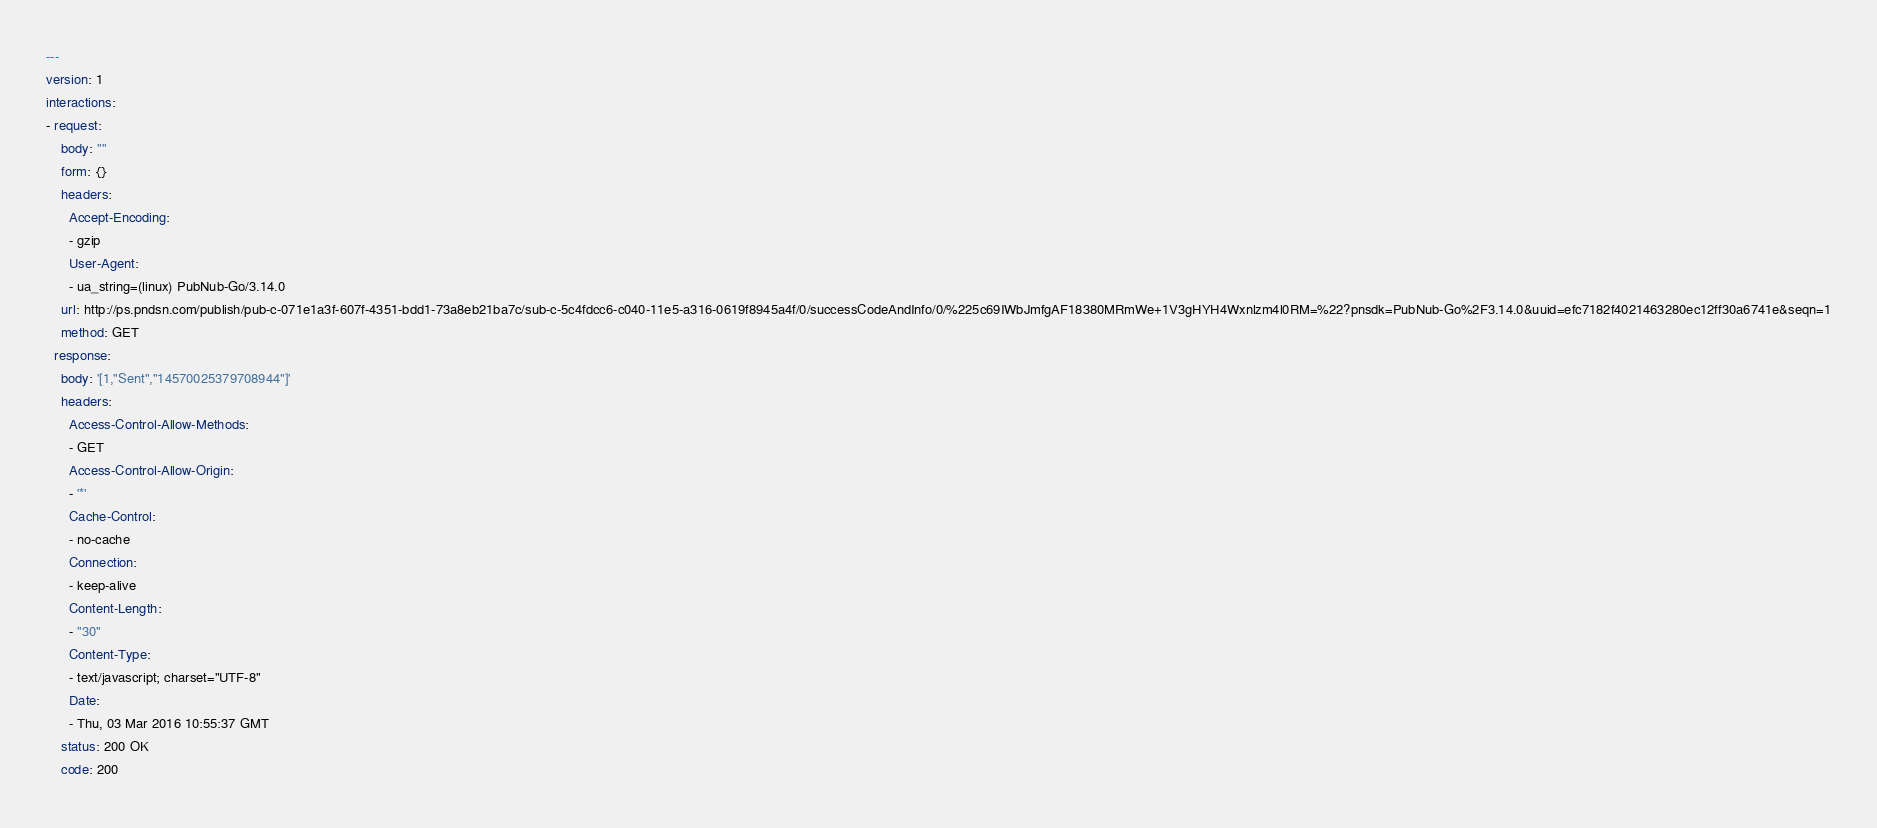<code> <loc_0><loc_0><loc_500><loc_500><_YAML_>---
version: 1
interactions:
- request:
    body: ""
    form: {}
    headers:
      Accept-Encoding:
      - gzip
      User-Agent:
      - ua_string=(linux) PubNub-Go/3.14.0
    url: http://ps.pndsn.com/publish/pub-c-071e1a3f-607f-4351-bdd1-73a8eb21ba7c/sub-c-5c4fdcc6-c040-11e5-a316-0619f8945a4f/0/successCodeAndInfo/0/%225c69IWbJmfgAF18380MRmWe+1V3gHYH4Wxnlzm4l0RM=%22?pnsdk=PubNub-Go%2F3.14.0&uuid=efc7182f4021463280ec12ff30a6741e&seqn=1
    method: GET
  response:
    body: '[1,"Sent","14570025379708944"]'
    headers:
      Access-Control-Allow-Methods:
      - GET
      Access-Control-Allow-Origin:
      - '*'
      Cache-Control:
      - no-cache
      Connection:
      - keep-alive
      Content-Length:
      - "30"
      Content-Type:
      - text/javascript; charset="UTF-8"
      Date:
      - Thu, 03 Mar 2016 10:55:37 GMT
    status: 200 OK
    code: 200
</code> 